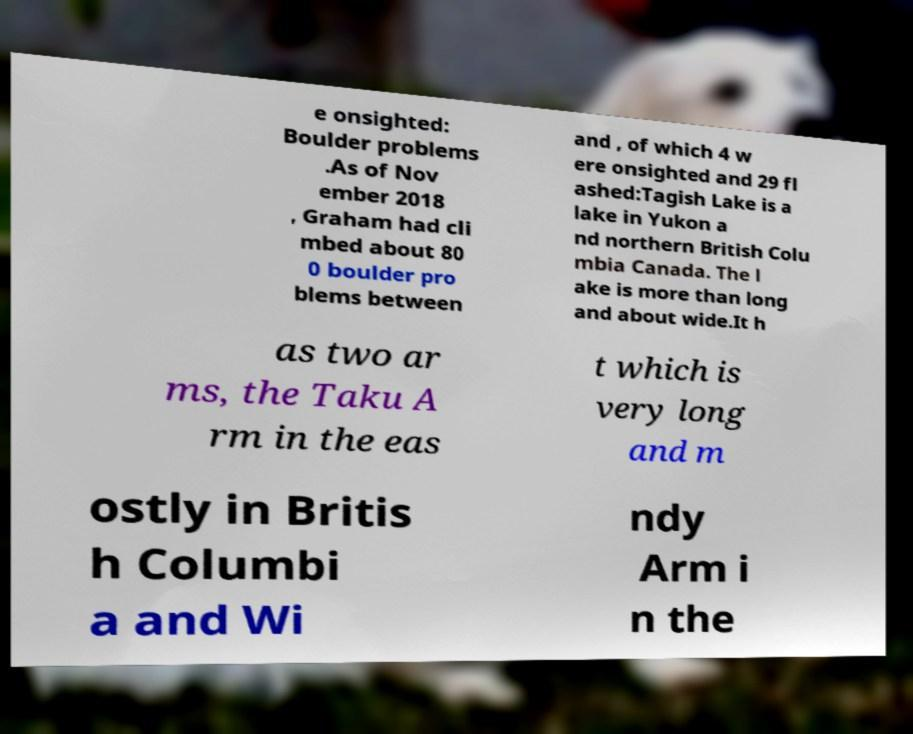Can you read and provide the text displayed in the image?This photo seems to have some interesting text. Can you extract and type it out for me? e onsighted: Boulder problems .As of Nov ember 2018 , Graham had cli mbed about 80 0 boulder pro blems between and , of which 4 w ere onsighted and 29 fl ashed:Tagish Lake is a lake in Yukon a nd northern British Colu mbia Canada. The l ake is more than long and about wide.It h as two ar ms, the Taku A rm in the eas t which is very long and m ostly in Britis h Columbi a and Wi ndy Arm i n the 